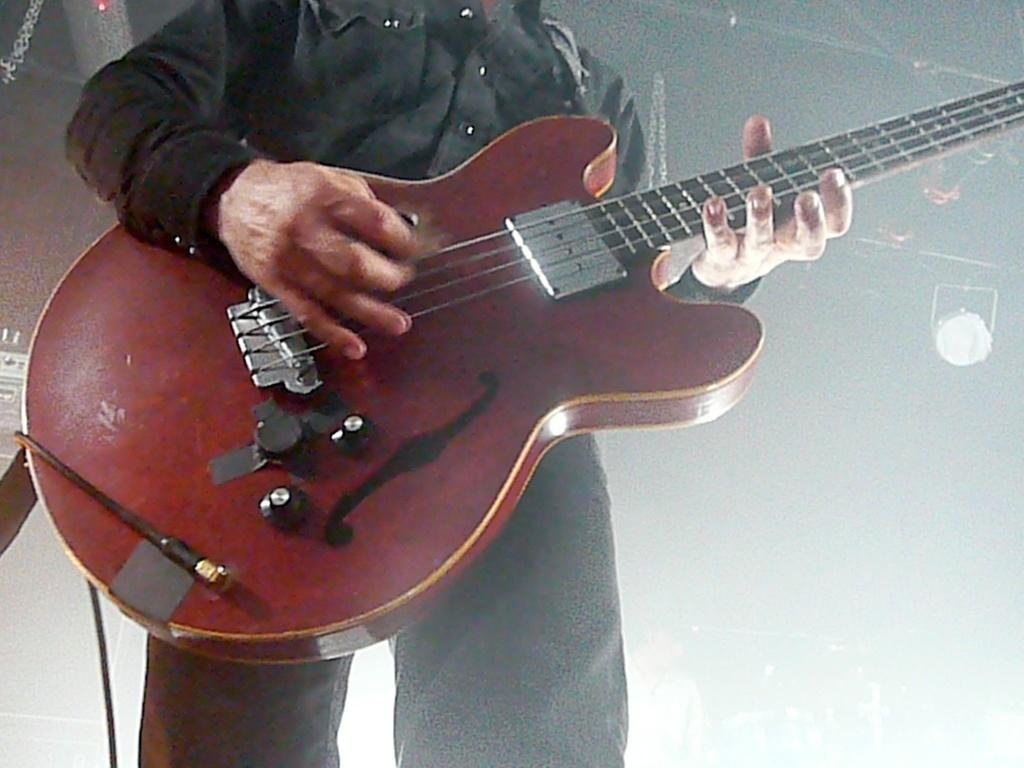What is the main subject of the image? The main subject of the image is a man. What is the man doing in the image? The man is standing and playing a guitar. What is the man holding in the image? The man is holding a guitar. What can be seen in the background of the image? There are lights in the background of the image, and the background is blurry. What type of education does the man have in the image? There is no information about the man's education in the image. Can you see a basket in the image? There is no basket present in the image. 